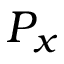<formula> <loc_0><loc_0><loc_500><loc_500>P _ { x }</formula> 